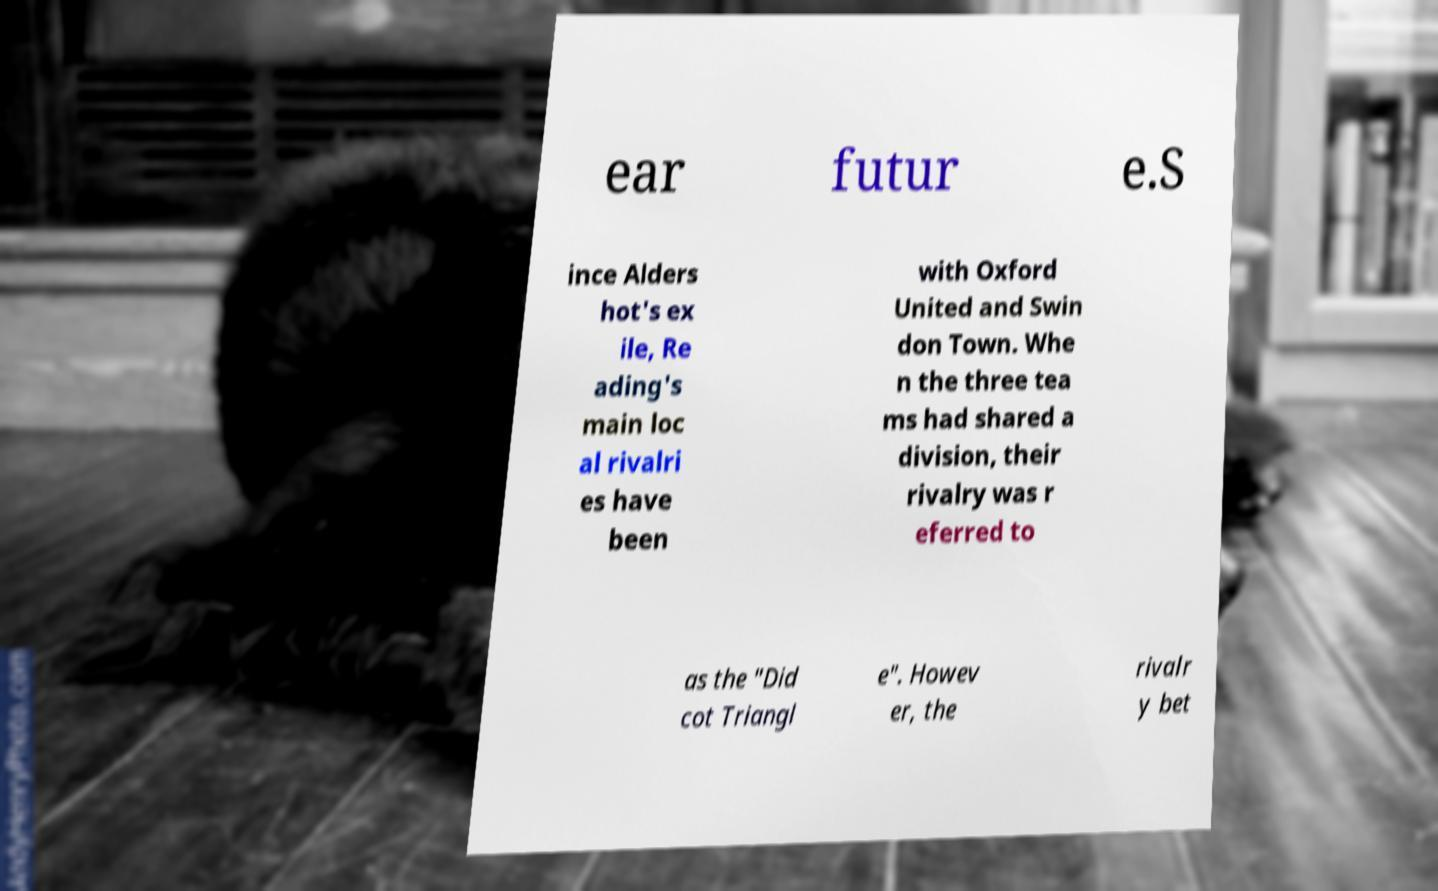Please identify and transcribe the text found in this image. ear futur e.S ince Alders hot's ex ile, Re ading's main loc al rivalri es have been with Oxford United and Swin don Town. Whe n the three tea ms had shared a division, their rivalry was r eferred to as the "Did cot Triangl e". Howev er, the rivalr y bet 